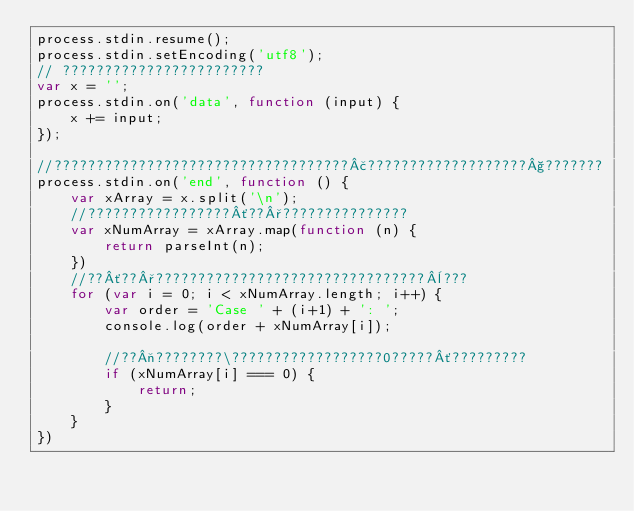Convert code to text. <code><loc_0><loc_0><loc_500><loc_500><_JavaScript_>process.stdin.resume();
process.stdin.setEncoding('utf8');
// ????????????????????????
var x = '';
process.stdin.on('data', function (input) {
    x += input;
});

//???????????????????????????????????£???????????????????§???????
process.stdin.on('end', function () {
    var xArray = x.split('\n');
    //?????????????????´??°???????????????
    var xNumArray = xArray.map(function (n) {
        return parseInt(n);
    })
    //??´??°????????????????????????????????¨???
    for (var i = 0; i < xNumArray.length; i++) {
        var order = 'Case ' + (i+1) + ': ';
        console.log(order + xNumArray[i]);

        //??¬????????\??????????????????0?????´?????????
        if (xNumArray[i] === 0) {
            return;
        }
    }
})</code> 